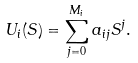<formula> <loc_0><loc_0><loc_500><loc_500>U _ { i } ( S ) = \sum _ { j = 0 } ^ { M _ { i } } a _ { i j } S ^ { j } .</formula> 